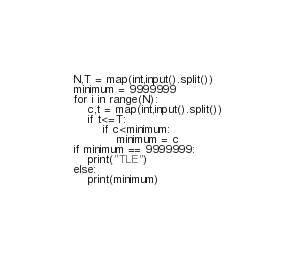Convert code to text. <code><loc_0><loc_0><loc_500><loc_500><_Python_>N,T = map(int,input().split())
minimum = 9999999
for i in range(N):
    c,t = map(int,input().split())
    if t<=T:
        if c<minimum:
            minimum = c
if minimum == 9999999:
    print("TLE")
else:
    print(minimum)</code> 